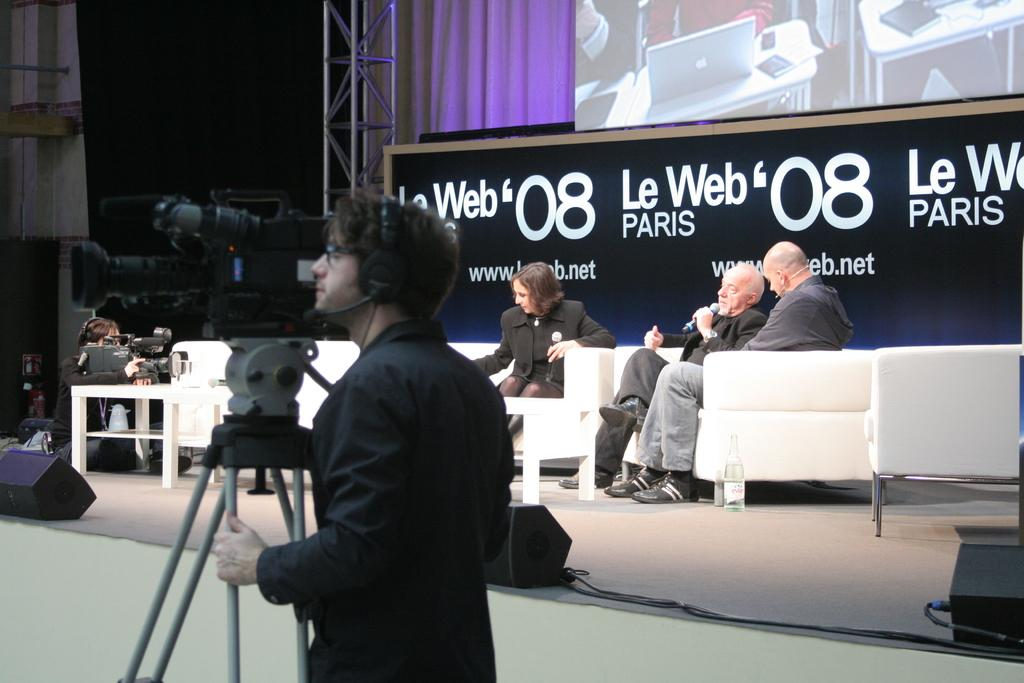What is the person in the image holding? The person in the image is holding a camera. What are the other people in the image doing? There are people sitting on chairs in the image. What can be seen on the board in the image? There is a board with text in the image. What is the purpose of the stand in the image? The stand in the image is likely used to support or display something. What type of drug is being discussed in the meeting in the image? There is no meeting or discussion of drugs in the image; it only shows a person holding a camera and other people sitting on chairs. 